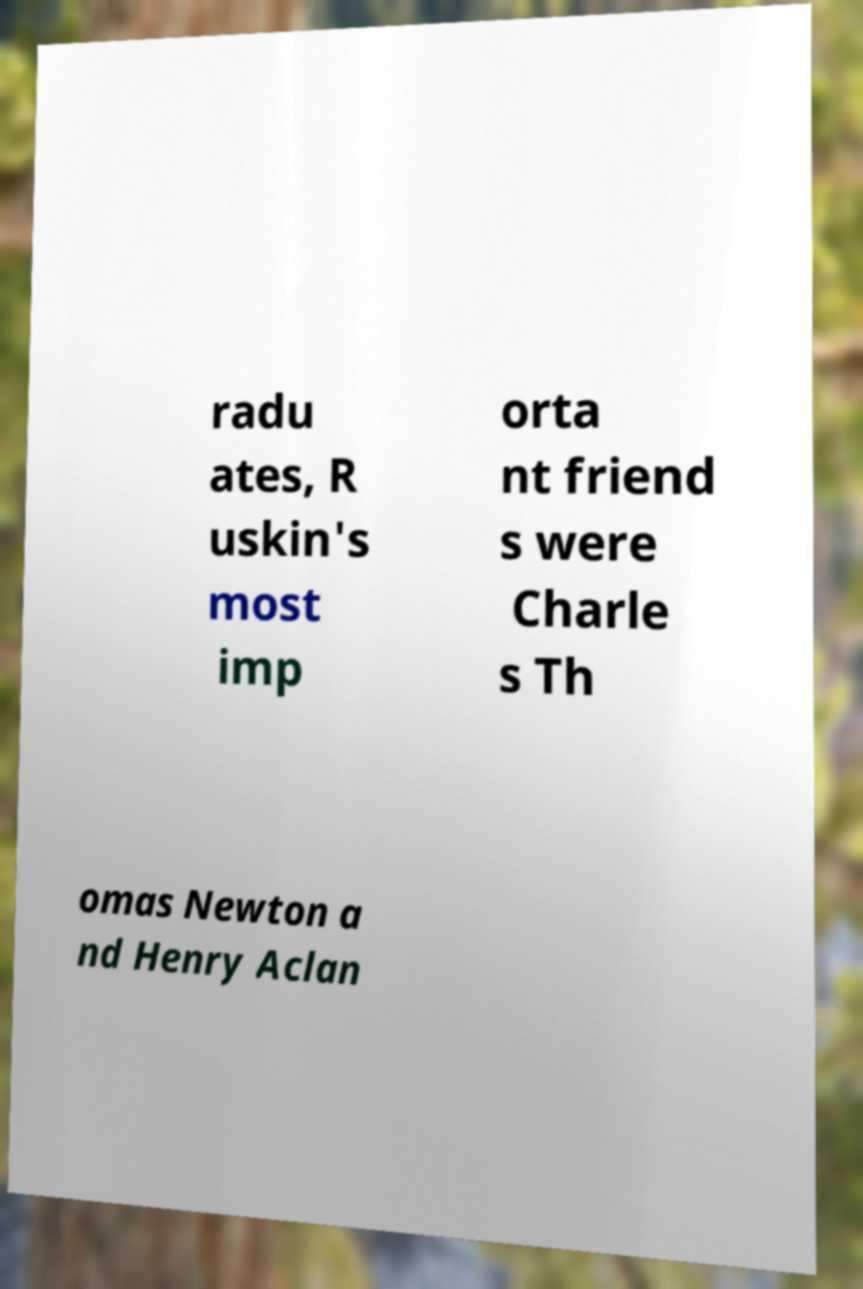Can you accurately transcribe the text from the provided image for me? radu ates, R uskin's most imp orta nt friend s were Charle s Th omas Newton a nd Henry Aclan 